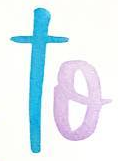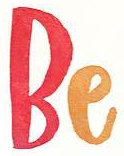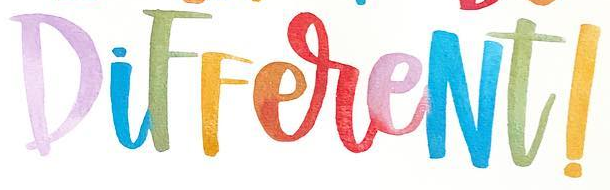Identify the words shown in these images in order, separated by a semicolon. to; Be; DiFFereNt! 